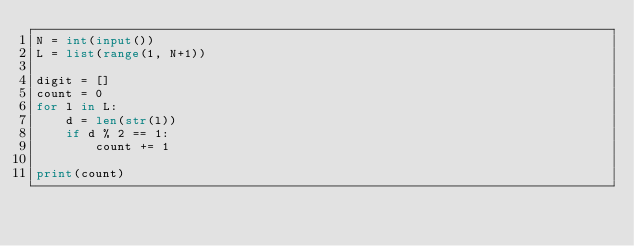Convert code to text. <code><loc_0><loc_0><loc_500><loc_500><_Python_>N = int(input())
L = list(range(1, N+1))

digit = []
count = 0
for l in L:
    d = len(str(l))
    if d % 2 == 1:
        count += 1

print(count)
</code> 